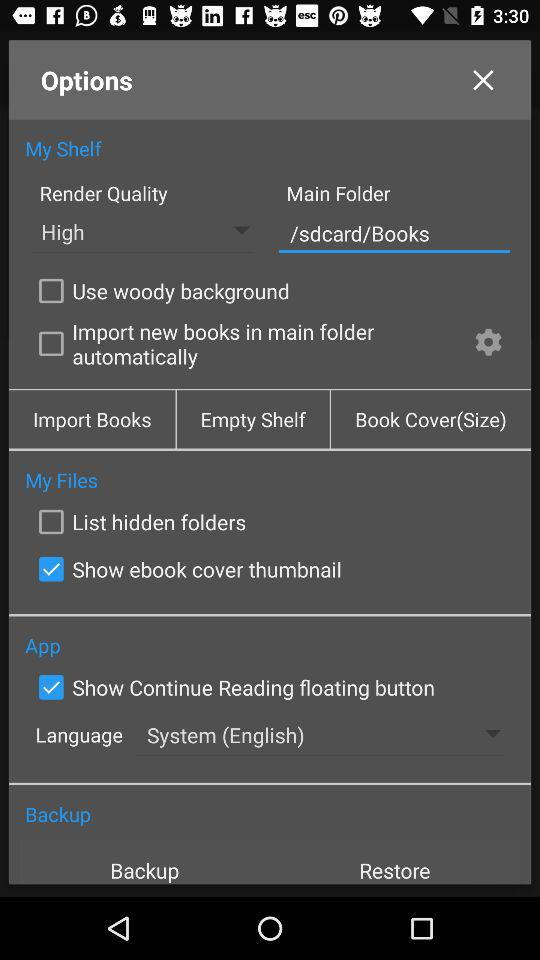What is the main folder? The main folder is "Books". 